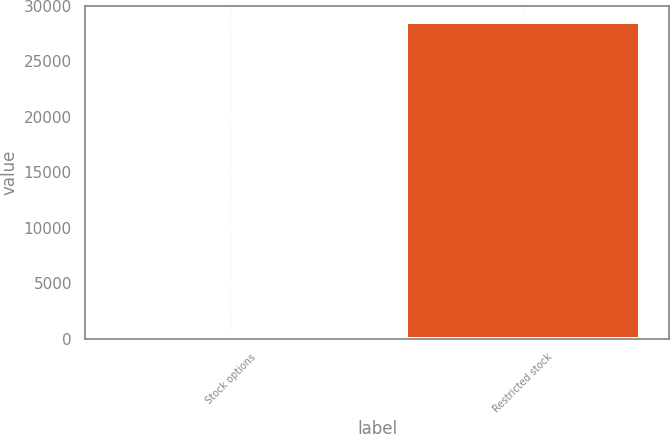Convert chart. <chart><loc_0><loc_0><loc_500><loc_500><bar_chart><fcel>Stock options<fcel>Restricted stock<nl><fcel>266<fcel>28603<nl></chart> 